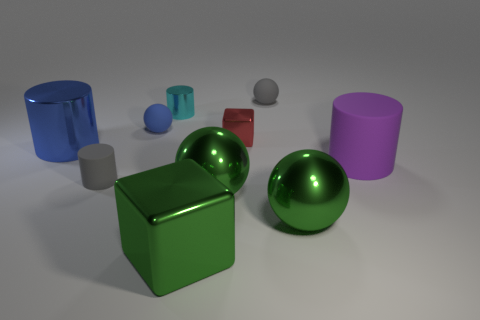There is a small thing that is the same color as the small rubber cylinder; what material is it?
Your response must be concise. Rubber. What number of rubber things are either large yellow cylinders or tiny gray things?
Offer a very short reply. 2. How many other things are the same shape as the small cyan metal object?
Ensure brevity in your answer.  3. Is the number of tiny gray objects greater than the number of small gray rubber blocks?
Keep it short and to the point. Yes. There is a gray thing in front of the tiny sphere that is in front of the small cylinder that is behind the gray cylinder; what is its size?
Offer a terse response. Small. What size is the metal cylinder that is in front of the blue matte ball?
Ensure brevity in your answer.  Large. What number of things are big shiny cylinders or spheres that are in front of the blue metal object?
Keep it short and to the point. 3. There is a small cyan thing that is the same shape as the big blue metallic object; what is it made of?
Keep it short and to the point. Metal. Is the number of green cubes left of the gray ball greater than the number of tiny blue cylinders?
Give a very brief answer. Yes. Are there any other things that are the same color as the large matte cylinder?
Give a very brief answer. No. 